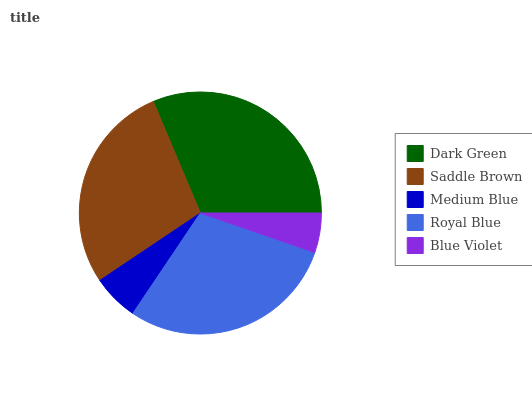Is Blue Violet the minimum?
Answer yes or no. Yes. Is Dark Green the maximum?
Answer yes or no. Yes. Is Saddle Brown the minimum?
Answer yes or no. No. Is Saddle Brown the maximum?
Answer yes or no. No. Is Dark Green greater than Saddle Brown?
Answer yes or no. Yes. Is Saddle Brown less than Dark Green?
Answer yes or no. Yes. Is Saddle Brown greater than Dark Green?
Answer yes or no. No. Is Dark Green less than Saddle Brown?
Answer yes or no. No. Is Saddle Brown the high median?
Answer yes or no. Yes. Is Saddle Brown the low median?
Answer yes or no. Yes. Is Medium Blue the high median?
Answer yes or no. No. Is Blue Violet the low median?
Answer yes or no. No. 